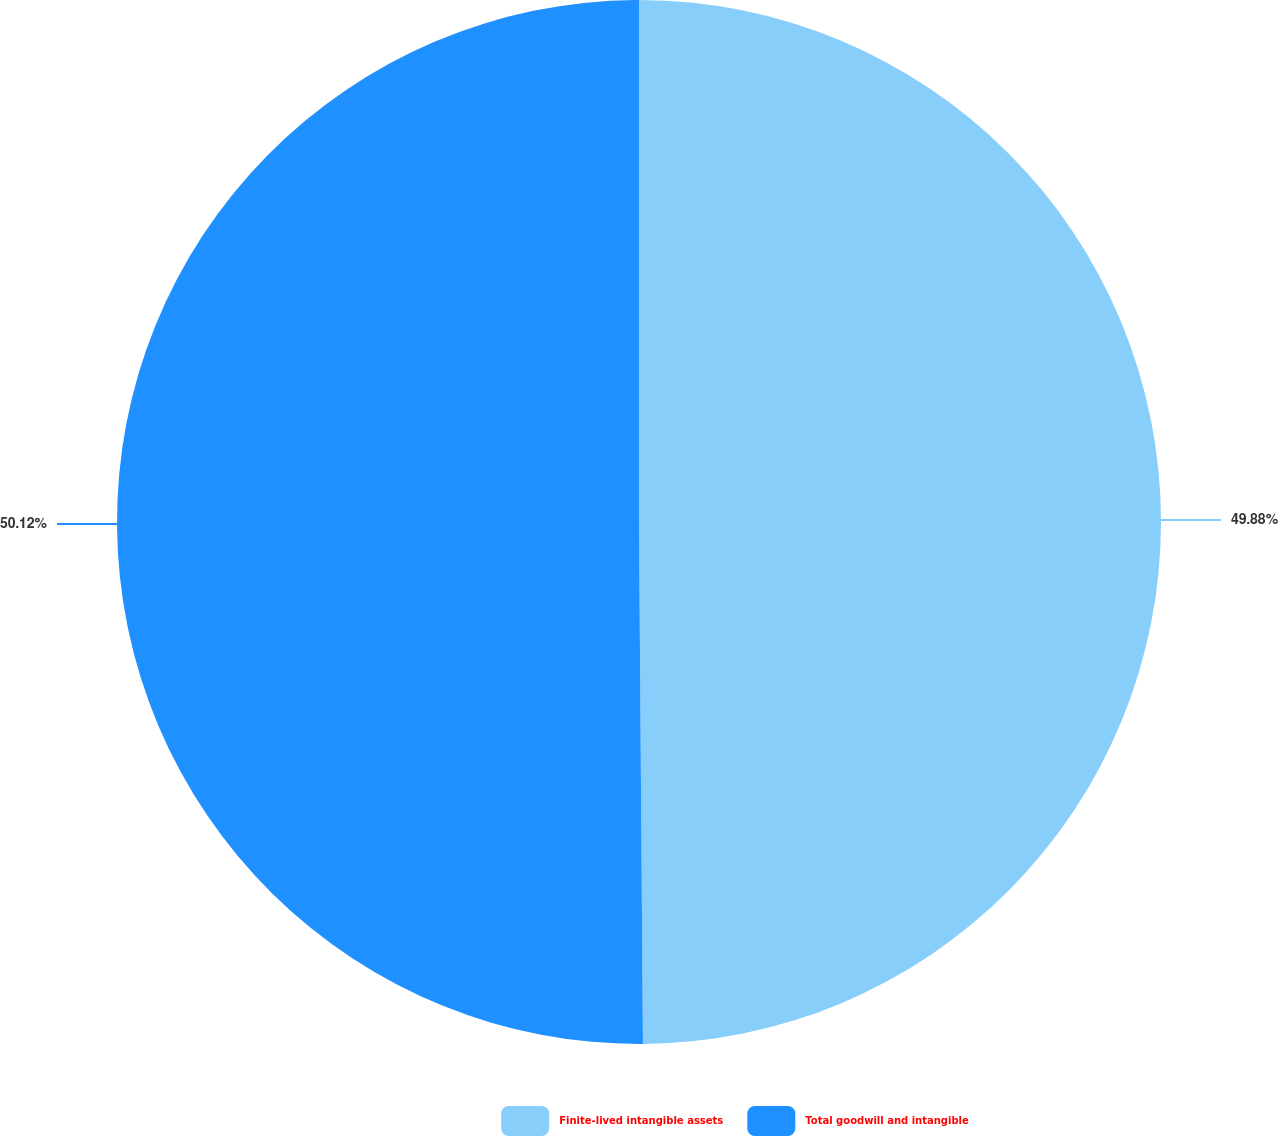Convert chart to OTSL. <chart><loc_0><loc_0><loc_500><loc_500><pie_chart><fcel>Finite-lived intangible assets<fcel>Total goodwill and intangible<nl><fcel>49.88%<fcel>50.12%<nl></chart> 